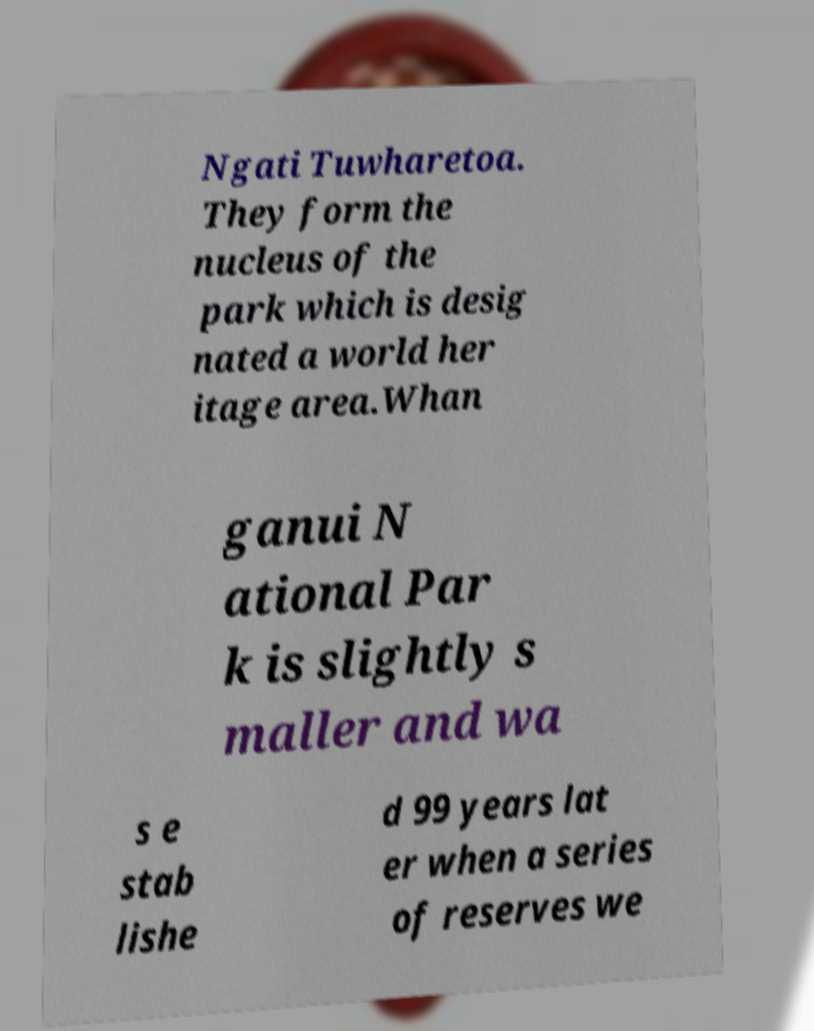Can you accurately transcribe the text from the provided image for me? Ngati Tuwharetoa. They form the nucleus of the park which is desig nated a world her itage area.Whan ganui N ational Par k is slightly s maller and wa s e stab lishe d 99 years lat er when a series of reserves we 